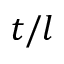<formula> <loc_0><loc_0><loc_500><loc_500>t / l</formula> 